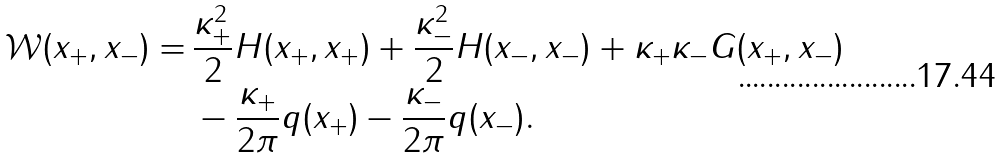<formula> <loc_0><loc_0><loc_500><loc_500>\mathcal { W } ( x _ { + } , x _ { - } ) = \, & \frac { \kappa _ { + } ^ { 2 } } { 2 } H ( x _ { + } , x _ { + } ) + \frac { \kappa _ { - } ^ { 2 } } { 2 } H ( x _ { - } , x _ { - } ) + \kappa _ { + } \kappa _ { - } G ( x _ { + } , x _ { - } ) \\ & - \frac { \kappa _ { + } } { 2 \pi } q ( x _ { + } ) - \frac { \kappa _ { - } } { 2 \pi } q ( x _ { - } ) .</formula> 